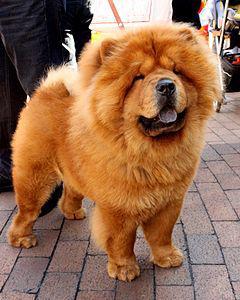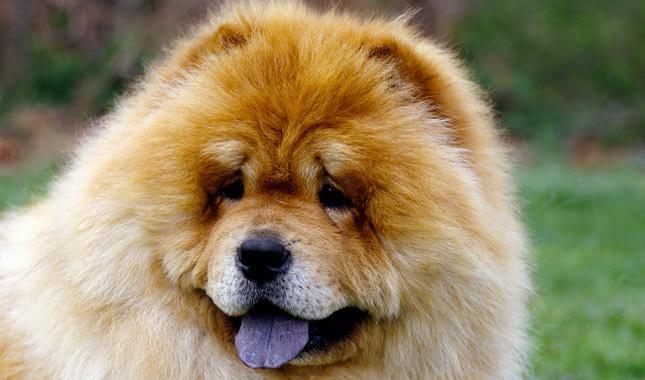The first image is the image on the left, the second image is the image on the right. Assess this claim about the two images: "One of the images only shows the head of a dog.". Correct or not? Answer yes or no. Yes. The first image is the image on the left, the second image is the image on the right. For the images displayed, is the sentence "An image shows a chow standing on a brick-type surface." factually correct? Answer yes or no. Yes. 